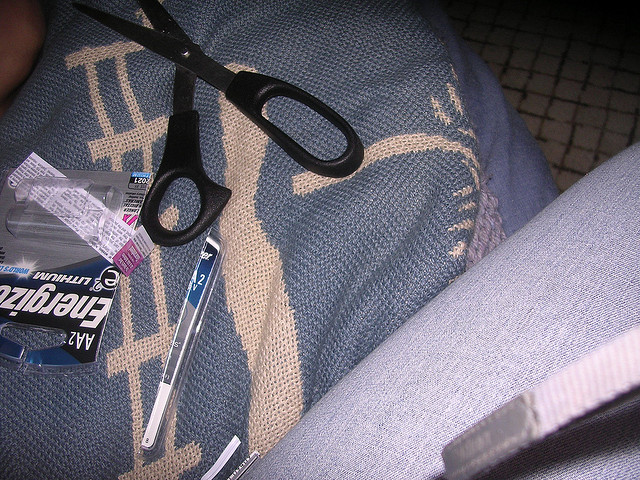Please identify all text content in this image. AA 2 Energizer LITHIUM 2 2 